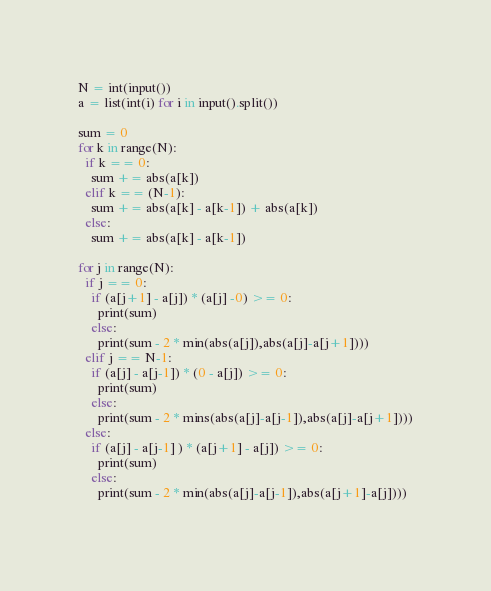<code> <loc_0><loc_0><loc_500><loc_500><_Python_>N = int(input())
a = list(int(i) for i in input().split())  

sum = 0
for k in range(N):
  if k == 0:
    sum += abs(a[k])
  elif k == (N-1):
    sum += abs(a[k] - a[k-1]) + abs(a[k])
  else:
    sum += abs(a[k] - a[k-1])

for j in range(N):
  if j == 0:
    if (a[j+1] - a[j]) * (a[j] -0) >= 0:
      print(sum)
    else:
      print(sum - 2 * min(abs(a[j]),abs(a[j]-a[j+1])))
  elif j == N-1:  
    if (a[j] - a[j-1]) * (0 - a[j]) >= 0:
      print(sum)
    else:
      print(sum - 2 * mins(abs(a[j]-a[j-1]),abs(a[j]-a[j+1])))
  else:
    if (a[j] - a[j-1] ) * (a[j+1] - a[j]) >= 0:
      print(sum)
    else:
      print(sum - 2 * min(abs(a[j]-a[j-1]),abs(a[j+1]-a[j])))
    </code> 